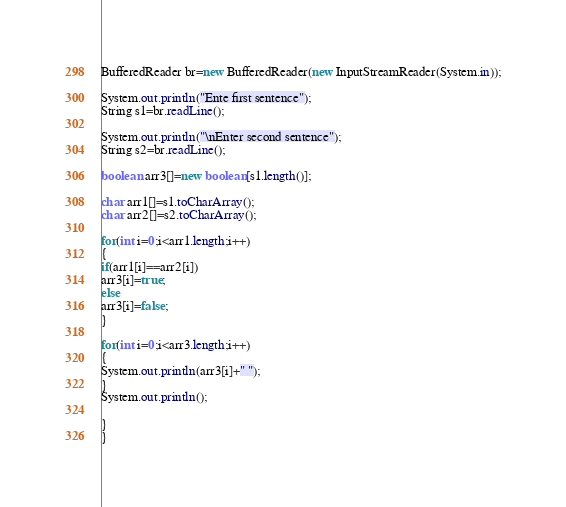<code> <loc_0><loc_0><loc_500><loc_500><_Java_>BufferedReader br=new BufferedReader(new InputStreamReader(System.in));

System.out.println("Ente first sentence");
String s1=br.readLine();

System.out.println("\nEnter second sentence");
String s2=br.readLine();

boolean arr3[]=new boolean[s1.length()];

char arr1[]=s1.toCharArray();
char arr2[]=s2.toCharArray();

for(int i=0;i<arr1.length;i++)
{
if(arr1[i]==arr2[i])
arr3[i]=true;
else
arr3[i]=false;
}

for(int i=0;i<arr3.length;i++)
{
System.out.println(arr3[i]+" ");
}
System.out.println();

}
}</code> 